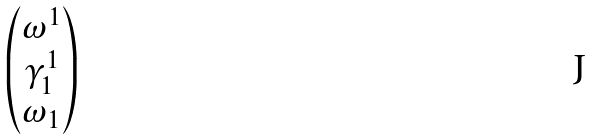<formula> <loc_0><loc_0><loc_500><loc_500>\begin{pmatrix} \omega ^ { 1 } \\ \gamma ^ { 1 } _ { 1 } \\ \omega _ { 1 } \end{pmatrix}</formula> 